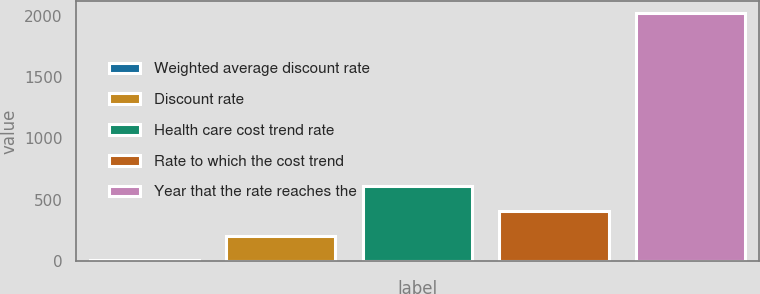<chart> <loc_0><loc_0><loc_500><loc_500><bar_chart><fcel>Weighted average discount rate<fcel>Discount rate<fcel>Health care cost trend rate<fcel>Rate to which the cost trend<fcel>Year that the rate reaches the<nl><fcel>4.19<fcel>205.77<fcel>608.93<fcel>407.35<fcel>2020<nl></chart> 